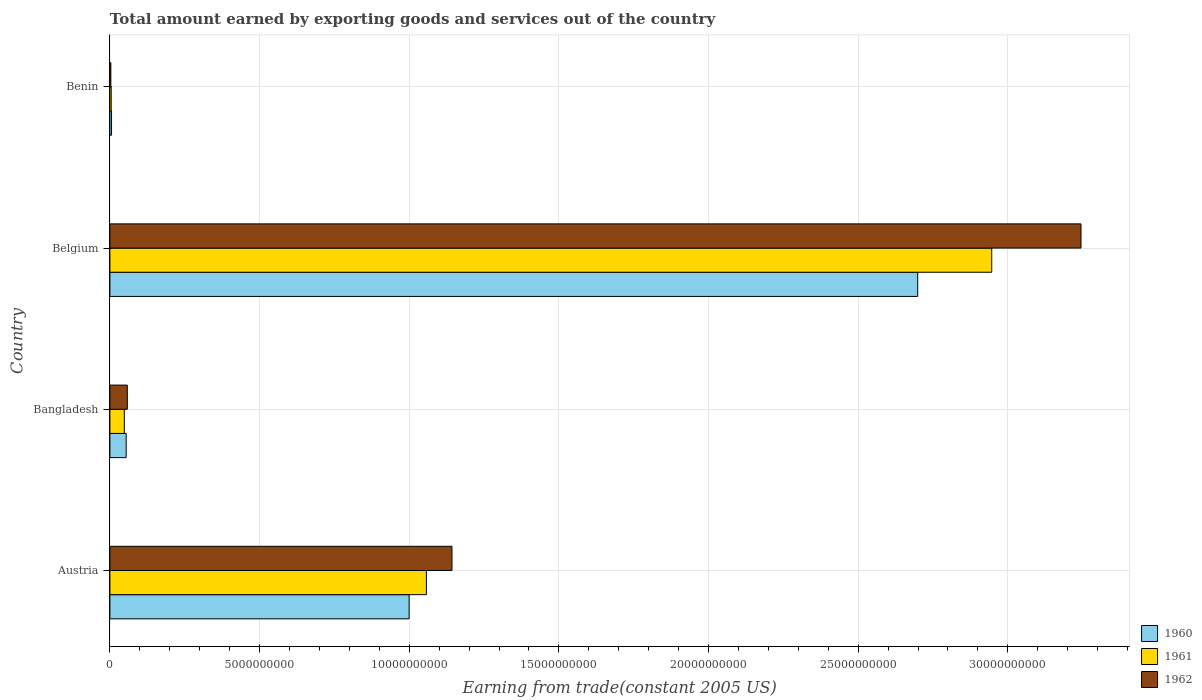How many groups of bars are there?
Provide a short and direct response. 4. Are the number of bars on each tick of the Y-axis equal?
Ensure brevity in your answer.  Yes. How many bars are there on the 2nd tick from the top?
Offer a terse response. 3. What is the label of the 1st group of bars from the top?
Offer a very short reply. Benin. In how many cases, is the number of bars for a given country not equal to the number of legend labels?
Give a very brief answer. 0. What is the total amount earned by exporting goods and services in 1961 in Austria?
Ensure brevity in your answer.  1.06e+1. Across all countries, what is the maximum total amount earned by exporting goods and services in 1962?
Keep it short and to the point. 3.24e+1. Across all countries, what is the minimum total amount earned by exporting goods and services in 1961?
Make the answer very short. 4.35e+07. In which country was the total amount earned by exporting goods and services in 1961 maximum?
Keep it short and to the point. Belgium. In which country was the total amount earned by exporting goods and services in 1960 minimum?
Your response must be concise. Benin. What is the total total amount earned by exporting goods and services in 1960 in the graph?
Provide a succinct answer. 3.76e+1. What is the difference between the total amount earned by exporting goods and services in 1962 in Bangladesh and that in Benin?
Provide a short and direct response. 5.50e+08. What is the difference between the total amount earned by exporting goods and services in 1962 in Austria and the total amount earned by exporting goods and services in 1961 in Belgium?
Keep it short and to the point. -1.80e+1. What is the average total amount earned by exporting goods and services in 1960 per country?
Offer a terse response. 9.40e+09. What is the difference between the total amount earned by exporting goods and services in 1961 and total amount earned by exporting goods and services in 1962 in Benin?
Offer a terse response. 1.15e+07. What is the ratio of the total amount earned by exporting goods and services in 1962 in Austria to that in Benin?
Give a very brief answer. 357.75. Is the total amount earned by exporting goods and services in 1961 in Austria less than that in Benin?
Make the answer very short. No. Is the difference between the total amount earned by exporting goods and services in 1961 in Belgium and Benin greater than the difference between the total amount earned by exporting goods and services in 1962 in Belgium and Benin?
Give a very brief answer. No. What is the difference between the highest and the second highest total amount earned by exporting goods and services in 1962?
Your answer should be compact. 2.10e+1. What is the difference between the highest and the lowest total amount earned by exporting goods and services in 1962?
Keep it short and to the point. 3.24e+1. What does the 3rd bar from the top in Austria represents?
Provide a succinct answer. 1960. Is it the case that in every country, the sum of the total amount earned by exporting goods and services in 1962 and total amount earned by exporting goods and services in 1961 is greater than the total amount earned by exporting goods and services in 1960?
Keep it short and to the point. Yes. How many countries are there in the graph?
Ensure brevity in your answer.  4. Does the graph contain any zero values?
Provide a short and direct response. No. What is the title of the graph?
Offer a terse response. Total amount earned by exporting goods and services out of the country. Does "1991" appear as one of the legend labels in the graph?
Make the answer very short. No. What is the label or title of the X-axis?
Provide a short and direct response. Earning from trade(constant 2005 US). What is the Earning from trade(constant 2005 US) of 1960 in Austria?
Provide a short and direct response. 1.00e+1. What is the Earning from trade(constant 2005 US) of 1961 in Austria?
Your answer should be very brief. 1.06e+1. What is the Earning from trade(constant 2005 US) in 1962 in Austria?
Give a very brief answer. 1.14e+1. What is the Earning from trade(constant 2005 US) in 1960 in Bangladesh?
Your answer should be compact. 5.45e+08. What is the Earning from trade(constant 2005 US) in 1961 in Bangladesh?
Ensure brevity in your answer.  4.82e+08. What is the Earning from trade(constant 2005 US) in 1962 in Bangladesh?
Make the answer very short. 5.82e+08. What is the Earning from trade(constant 2005 US) in 1960 in Belgium?
Your answer should be compact. 2.70e+1. What is the Earning from trade(constant 2005 US) of 1961 in Belgium?
Ensure brevity in your answer.  2.95e+1. What is the Earning from trade(constant 2005 US) of 1962 in Belgium?
Your answer should be compact. 3.24e+1. What is the Earning from trade(constant 2005 US) of 1960 in Benin?
Your answer should be compact. 5.55e+07. What is the Earning from trade(constant 2005 US) of 1961 in Benin?
Offer a very short reply. 4.35e+07. What is the Earning from trade(constant 2005 US) of 1962 in Benin?
Your response must be concise. 3.19e+07. Across all countries, what is the maximum Earning from trade(constant 2005 US) in 1960?
Give a very brief answer. 2.70e+1. Across all countries, what is the maximum Earning from trade(constant 2005 US) of 1961?
Offer a terse response. 2.95e+1. Across all countries, what is the maximum Earning from trade(constant 2005 US) in 1962?
Give a very brief answer. 3.24e+1. Across all countries, what is the minimum Earning from trade(constant 2005 US) of 1960?
Provide a succinct answer. 5.55e+07. Across all countries, what is the minimum Earning from trade(constant 2005 US) of 1961?
Your response must be concise. 4.35e+07. Across all countries, what is the minimum Earning from trade(constant 2005 US) in 1962?
Give a very brief answer. 3.19e+07. What is the total Earning from trade(constant 2005 US) of 1960 in the graph?
Give a very brief answer. 3.76e+1. What is the total Earning from trade(constant 2005 US) in 1961 in the graph?
Ensure brevity in your answer.  4.06e+1. What is the total Earning from trade(constant 2005 US) in 1962 in the graph?
Your response must be concise. 4.45e+1. What is the difference between the Earning from trade(constant 2005 US) in 1960 in Austria and that in Bangladesh?
Keep it short and to the point. 9.45e+09. What is the difference between the Earning from trade(constant 2005 US) in 1961 in Austria and that in Bangladesh?
Provide a succinct answer. 1.01e+1. What is the difference between the Earning from trade(constant 2005 US) in 1962 in Austria and that in Bangladesh?
Provide a succinct answer. 1.08e+1. What is the difference between the Earning from trade(constant 2005 US) in 1960 in Austria and that in Belgium?
Ensure brevity in your answer.  -1.70e+1. What is the difference between the Earning from trade(constant 2005 US) of 1961 in Austria and that in Belgium?
Give a very brief answer. -1.89e+1. What is the difference between the Earning from trade(constant 2005 US) in 1962 in Austria and that in Belgium?
Your answer should be compact. -2.10e+1. What is the difference between the Earning from trade(constant 2005 US) of 1960 in Austria and that in Benin?
Make the answer very short. 9.94e+09. What is the difference between the Earning from trade(constant 2005 US) in 1961 in Austria and that in Benin?
Keep it short and to the point. 1.05e+1. What is the difference between the Earning from trade(constant 2005 US) in 1962 in Austria and that in Benin?
Give a very brief answer. 1.14e+1. What is the difference between the Earning from trade(constant 2005 US) in 1960 in Bangladesh and that in Belgium?
Make the answer very short. -2.64e+1. What is the difference between the Earning from trade(constant 2005 US) in 1961 in Bangladesh and that in Belgium?
Your answer should be compact. -2.90e+1. What is the difference between the Earning from trade(constant 2005 US) of 1962 in Bangladesh and that in Belgium?
Ensure brevity in your answer.  -3.19e+1. What is the difference between the Earning from trade(constant 2005 US) in 1960 in Bangladesh and that in Benin?
Offer a very short reply. 4.89e+08. What is the difference between the Earning from trade(constant 2005 US) in 1961 in Bangladesh and that in Benin?
Your response must be concise. 4.38e+08. What is the difference between the Earning from trade(constant 2005 US) in 1962 in Bangladesh and that in Benin?
Offer a very short reply. 5.50e+08. What is the difference between the Earning from trade(constant 2005 US) of 1960 in Belgium and that in Benin?
Your answer should be compact. 2.69e+1. What is the difference between the Earning from trade(constant 2005 US) of 1961 in Belgium and that in Benin?
Provide a succinct answer. 2.94e+1. What is the difference between the Earning from trade(constant 2005 US) of 1962 in Belgium and that in Benin?
Offer a very short reply. 3.24e+1. What is the difference between the Earning from trade(constant 2005 US) in 1960 in Austria and the Earning from trade(constant 2005 US) in 1961 in Bangladesh?
Ensure brevity in your answer.  9.52e+09. What is the difference between the Earning from trade(constant 2005 US) in 1960 in Austria and the Earning from trade(constant 2005 US) in 1962 in Bangladesh?
Give a very brief answer. 9.42e+09. What is the difference between the Earning from trade(constant 2005 US) of 1961 in Austria and the Earning from trade(constant 2005 US) of 1962 in Bangladesh?
Your response must be concise. 9.99e+09. What is the difference between the Earning from trade(constant 2005 US) in 1960 in Austria and the Earning from trade(constant 2005 US) in 1961 in Belgium?
Ensure brevity in your answer.  -1.95e+1. What is the difference between the Earning from trade(constant 2005 US) in 1960 in Austria and the Earning from trade(constant 2005 US) in 1962 in Belgium?
Offer a terse response. -2.24e+1. What is the difference between the Earning from trade(constant 2005 US) of 1961 in Austria and the Earning from trade(constant 2005 US) of 1962 in Belgium?
Keep it short and to the point. -2.19e+1. What is the difference between the Earning from trade(constant 2005 US) of 1960 in Austria and the Earning from trade(constant 2005 US) of 1961 in Benin?
Your answer should be compact. 9.95e+09. What is the difference between the Earning from trade(constant 2005 US) in 1960 in Austria and the Earning from trade(constant 2005 US) in 1962 in Benin?
Your answer should be very brief. 9.97e+09. What is the difference between the Earning from trade(constant 2005 US) in 1961 in Austria and the Earning from trade(constant 2005 US) in 1962 in Benin?
Ensure brevity in your answer.  1.05e+1. What is the difference between the Earning from trade(constant 2005 US) of 1960 in Bangladesh and the Earning from trade(constant 2005 US) of 1961 in Belgium?
Make the answer very short. -2.89e+1. What is the difference between the Earning from trade(constant 2005 US) in 1960 in Bangladesh and the Earning from trade(constant 2005 US) in 1962 in Belgium?
Keep it short and to the point. -3.19e+1. What is the difference between the Earning from trade(constant 2005 US) of 1961 in Bangladesh and the Earning from trade(constant 2005 US) of 1962 in Belgium?
Your answer should be very brief. -3.20e+1. What is the difference between the Earning from trade(constant 2005 US) of 1960 in Bangladesh and the Earning from trade(constant 2005 US) of 1961 in Benin?
Provide a short and direct response. 5.01e+08. What is the difference between the Earning from trade(constant 2005 US) of 1960 in Bangladesh and the Earning from trade(constant 2005 US) of 1962 in Benin?
Your answer should be compact. 5.13e+08. What is the difference between the Earning from trade(constant 2005 US) of 1961 in Bangladesh and the Earning from trade(constant 2005 US) of 1962 in Benin?
Offer a terse response. 4.50e+08. What is the difference between the Earning from trade(constant 2005 US) in 1960 in Belgium and the Earning from trade(constant 2005 US) in 1961 in Benin?
Offer a terse response. 2.69e+1. What is the difference between the Earning from trade(constant 2005 US) of 1960 in Belgium and the Earning from trade(constant 2005 US) of 1962 in Benin?
Your response must be concise. 2.70e+1. What is the difference between the Earning from trade(constant 2005 US) of 1961 in Belgium and the Earning from trade(constant 2005 US) of 1962 in Benin?
Offer a very short reply. 2.94e+1. What is the average Earning from trade(constant 2005 US) of 1960 per country?
Your answer should be compact. 9.40e+09. What is the average Earning from trade(constant 2005 US) of 1961 per country?
Give a very brief answer. 1.01e+1. What is the average Earning from trade(constant 2005 US) of 1962 per country?
Make the answer very short. 1.11e+1. What is the difference between the Earning from trade(constant 2005 US) of 1960 and Earning from trade(constant 2005 US) of 1961 in Austria?
Provide a short and direct response. -5.77e+08. What is the difference between the Earning from trade(constant 2005 US) in 1960 and Earning from trade(constant 2005 US) in 1962 in Austria?
Provide a short and direct response. -1.43e+09. What is the difference between the Earning from trade(constant 2005 US) of 1961 and Earning from trade(constant 2005 US) of 1962 in Austria?
Make the answer very short. -8.54e+08. What is the difference between the Earning from trade(constant 2005 US) of 1960 and Earning from trade(constant 2005 US) of 1961 in Bangladesh?
Your response must be concise. 6.26e+07. What is the difference between the Earning from trade(constant 2005 US) in 1960 and Earning from trade(constant 2005 US) in 1962 in Bangladesh?
Keep it short and to the point. -3.76e+07. What is the difference between the Earning from trade(constant 2005 US) in 1961 and Earning from trade(constant 2005 US) in 1962 in Bangladesh?
Your answer should be compact. -1.00e+08. What is the difference between the Earning from trade(constant 2005 US) of 1960 and Earning from trade(constant 2005 US) of 1961 in Belgium?
Your response must be concise. -2.47e+09. What is the difference between the Earning from trade(constant 2005 US) of 1960 and Earning from trade(constant 2005 US) of 1962 in Belgium?
Offer a very short reply. -5.46e+09. What is the difference between the Earning from trade(constant 2005 US) in 1961 and Earning from trade(constant 2005 US) in 1962 in Belgium?
Ensure brevity in your answer.  -2.98e+09. What is the difference between the Earning from trade(constant 2005 US) in 1960 and Earning from trade(constant 2005 US) in 1961 in Benin?
Your answer should be compact. 1.20e+07. What is the difference between the Earning from trade(constant 2005 US) of 1960 and Earning from trade(constant 2005 US) of 1962 in Benin?
Ensure brevity in your answer.  2.36e+07. What is the difference between the Earning from trade(constant 2005 US) of 1961 and Earning from trade(constant 2005 US) of 1962 in Benin?
Give a very brief answer. 1.15e+07. What is the ratio of the Earning from trade(constant 2005 US) in 1960 in Austria to that in Bangladesh?
Offer a terse response. 18.36. What is the ratio of the Earning from trade(constant 2005 US) of 1961 in Austria to that in Bangladesh?
Ensure brevity in your answer.  21.94. What is the ratio of the Earning from trade(constant 2005 US) of 1962 in Austria to that in Bangladesh?
Make the answer very short. 19.63. What is the ratio of the Earning from trade(constant 2005 US) of 1960 in Austria to that in Belgium?
Your response must be concise. 0.37. What is the ratio of the Earning from trade(constant 2005 US) in 1961 in Austria to that in Belgium?
Make the answer very short. 0.36. What is the ratio of the Earning from trade(constant 2005 US) in 1962 in Austria to that in Belgium?
Make the answer very short. 0.35. What is the ratio of the Earning from trade(constant 2005 US) in 1960 in Austria to that in Benin?
Ensure brevity in your answer.  180.09. What is the ratio of the Earning from trade(constant 2005 US) in 1961 in Austria to that in Benin?
Your answer should be compact. 243.27. What is the ratio of the Earning from trade(constant 2005 US) of 1962 in Austria to that in Benin?
Your answer should be very brief. 357.75. What is the ratio of the Earning from trade(constant 2005 US) of 1960 in Bangladesh to that in Belgium?
Offer a very short reply. 0.02. What is the ratio of the Earning from trade(constant 2005 US) of 1961 in Bangladesh to that in Belgium?
Your answer should be compact. 0.02. What is the ratio of the Earning from trade(constant 2005 US) in 1962 in Bangladesh to that in Belgium?
Make the answer very short. 0.02. What is the ratio of the Earning from trade(constant 2005 US) in 1960 in Bangladesh to that in Benin?
Keep it short and to the point. 9.81. What is the ratio of the Earning from trade(constant 2005 US) in 1961 in Bangladesh to that in Benin?
Your answer should be compact. 11.09. What is the ratio of the Earning from trade(constant 2005 US) in 1962 in Bangladesh to that in Benin?
Provide a short and direct response. 18.22. What is the ratio of the Earning from trade(constant 2005 US) of 1960 in Belgium to that in Benin?
Keep it short and to the point. 486.17. What is the ratio of the Earning from trade(constant 2005 US) in 1961 in Belgium to that in Benin?
Make the answer very short. 677.79. What is the ratio of the Earning from trade(constant 2005 US) of 1962 in Belgium to that in Benin?
Keep it short and to the point. 1015.59. What is the difference between the highest and the second highest Earning from trade(constant 2005 US) in 1960?
Offer a terse response. 1.70e+1. What is the difference between the highest and the second highest Earning from trade(constant 2005 US) of 1961?
Provide a short and direct response. 1.89e+1. What is the difference between the highest and the second highest Earning from trade(constant 2005 US) of 1962?
Make the answer very short. 2.10e+1. What is the difference between the highest and the lowest Earning from trade(constant 2005 US) of 1960?
Offer a very short reply. 2.69e+1. What is the difference between the highest and the lowest Earning from trade(constant 2005 US) of 1961?
Provide a short and direct response. 2.94e+1. What is the difference between the highest and the lowest Earning from trade(constant 2005 US) in 1962?
Offer a very short reply. 3.24e+1. 